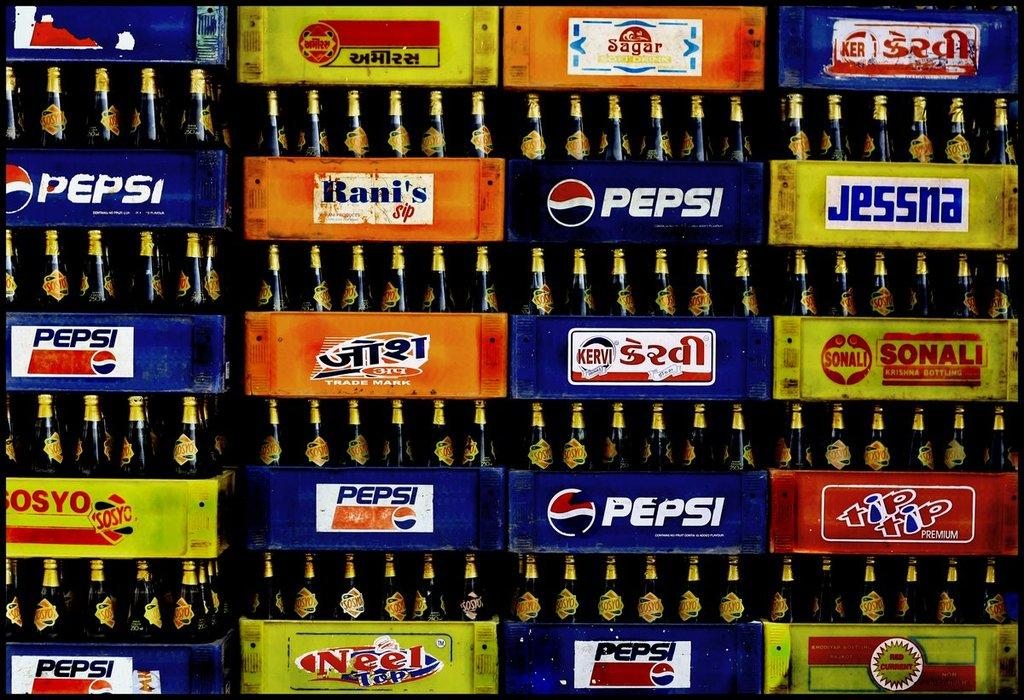<image>
Create a compact narrative representing the image presented. A stack of bottles in crates that say Pepsi. 